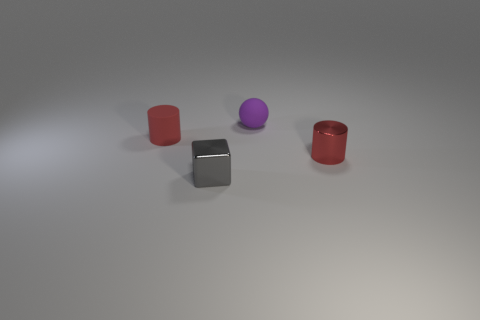What number of other things are the same color as the ball?
Give a very brief answer. 0. What material is the cylinder to the right of the tiny cylinder that is on the left side of the gray cube?
Your answer should be compact. Metal. Are any large yellow metallic cylinders visible?
Keep it short and to the point. No. Is the number of cylinders behind the matte cylinder greater than the number of tiny metallic objects that are on the left side of the purple object?
Provide a short and direct response. No. How many spheres are either big gray rubber things or tiny red objects?
Your answer should be very brief. 0. There is a red object left of the small gray object; is its shape the same as the gray metallic thing?
Your response must be concise. No. The block is what color?
Provide a succinct answer. Gray. The other object that is the same shape as the red metal thing is what color?
Ensure brevity in your answer.  Red. How many other small objects are the same shape as the red metal object?
Give a very brief answer. 1. How many objects are small purple things or red cylinders on the right side of the shiny cube?
Offer a very short reply. 2. 